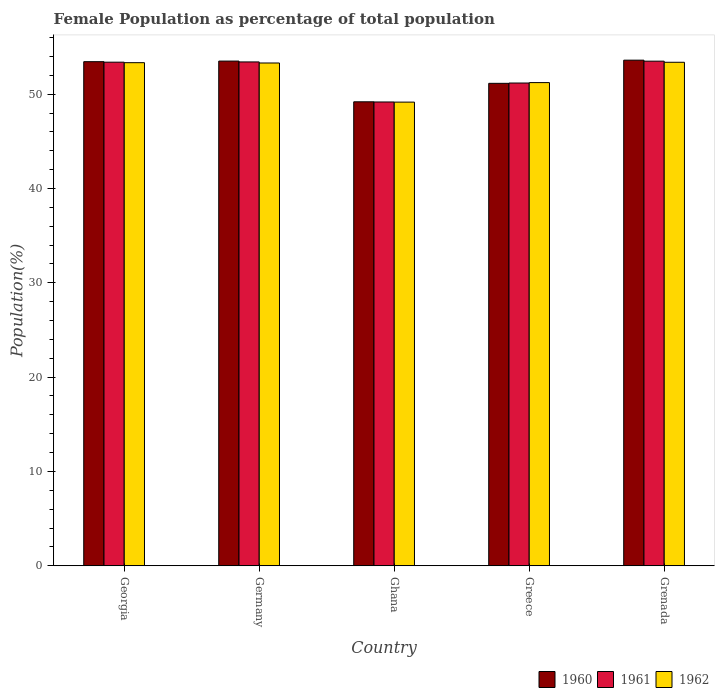Are the number of bars per tick equal to the number of legend labels?
Offer a terse response. Yes. How many bars are there on the 1st tick from the right?
Keep it short and to the point. 3. What is the label of the 5th group of bars from the left?
Your answer should be compact. Grenada. What is the female population in in 1960 in Georgia?
Offer a very short reply. 53.44. Across all countries, what is the maximum female population in in 1961?
Provide a succinct answer. 53.5. Across all countries, what is the minimum female population in in 1962?
Offer a terse response. 49.15. In which country was the female population in in 1960 maximum?
Keep it short and to the point. Grenada. What is the total female population in in 1961 in the graph?
Your answer should be very brief. 260.65. What is the difference between the female population in in 1960 in Germany and that in Greece?
Provide a short and direct response. 2.36. What is the difference between the female population in in 1962 in Greece and the female population in in 1960 in Ghana?
Offer a terse response. 2.04. What is the average female population in in 1961 per country?
Offer a terse response. 52.13. What is the difference between the female population in of/in 1962 and female population in of/in 1961 in Germany?
Keep it short and to the point. -0.11. What is the ratio of the female population in in 1962 in Germany to that in Greece?
Your response must be concise. 1.04. Is the difference between the female population in in 1962 in Georgia and Ghana greater than the difference between the female population in in 1961 in Georgia and Ghana?
Provide a short and direct response. No. What is the difference between the highest and the second highest female population in in 1962?
Keep it short and to the point. -0.03. What is the difference between the highest and the lowest female population in in 1962?
Keep it short and to the point. 4.22. Is the sum of the female population in in 1962 in Georgia and Greece greater than the maximum female population in in 1961 across all countries?
Give a very brief answer. Yes. Is it the case that in every country, the sum of the female population in in 1961 and female population in in 1960 is greater than the female population in in 1962?
Provide a succinct answer. Yes. What is the difference between two consecutive major ticks on the Y-axis?
Offer a terse response. 10. Does the graph contain any zero values?
Your answer should be very brief. No. How are the legend labels stacked?
Offer a terse response. Horizontal. What is the title of the graph?
Provide a succinct answer. Female Population as percentage of total population. What is the label or title of the Y-axis?
Give a very brief answer. Population(%). What is the Population(%) of 1960 in Georgia?
Give a very brief answer. 53.44. What is the Population(%) of 1961 in Georgia?
Make the answer very short. 53.39. What is the Population(%) of 1962 in Georgia?
Offer a very short reply. 53.34. What is the Population(%) of 1960 in Germany?
Provide a short and direct response. 53.5. What is the Population(%) of 1961 in Germany?
Keep it short and to the point. 53.42. What is the Population(%) of 1962 in Germany?
Make the answer very short. 53.3. What is the Population(%) in 1960 in Ghana?
Keep it short and to the point. 49.19. What is the Population(%) in 1961 in Ghana?
Offer a very short reply. 49.17. What is the Population(%) in 1962 in Ghana?
Provide a short and direct response. 49.15. What is the Population(%) in 1960 in Greece?
Make the answer very short. 51.14. What is the Population(%) of 1961 in Greece?
Offer a terse response. 51.18. What is the Population(%) in 1962 in Greece?
Provide a succinct answer. 51.22. What is the Population(%) in 1960 in Grenada?
Provide a succinct answer. 53.6. What is the Population(%) of 1961 in Grenada?
Offer a terse response. 53.5. What is the Population(%) of 1962 in Grenada?
Provide a short and direct response. 53.38. Across all countries, what is the maximum Population(%) in 1960?
Keep it short and to the point. 53.6. Across all countries, what is the maximum Population(%) in 1961?
Make the answer very short. 53.5. Across all countries, what is the maximum Population(%) in 1962?
Keep it short and to the point. 53.38. Across all countries, what is the minimum Population(%) in 1960?
Provide a short and direct response. 49.19. Across all countries, what is the minimum Population(%) of 1961?
Make the answer very short. 49.17. Across all countries, what is the minimum Population(%) in 1962?
Keep it short and to the point. 49.15. What is the total Population(%) in 1960 in the graph?
Offer a very short reply. 260.88. What is the total Population(%) of 1961 in the graph?
Offer a terse response. 260.65. What is the total Population(%) of 1962 in the graph?
Make the answer very short. 260.39. What is the difference between the Population(%) in 1960 in Georgia and that in Germany?
Give a very brief answer. -0.06. What is the difference between the Population(%) in 1961 in Georgia and that in Germany?
Give a very brief answer. -0.03. What is the difference between the Population(%) in 1962 in Georgia and that in Germany?
Give a very brief answer. 0.03. What is the difference between the Population(%) in 1960 in Georgia and that in Ghana?
Provide a succinct answer. 4.25. What is the difference between the Population(%) of 1961 in Georgia and that in Ghana?
Give a very brief answer. 4.22. What is the difference between the Population(%) in 1962 in Georgia and that in Ghana?
Provide a succinct answer. 4.18. What is the difference between the Population(%) of 1960 in Georgia and that in Greece?
Give a very brief answer. 2.3. What is the difference between the Population(%) in 1961 in Georgia and that in Greece?
Offer a terse response. 2.21. What is the difference between the Population(%) in 1962 in Georgia and that in Greece?
Provide a short and direct response. 2.11. What is the difference between the Population(%) of 1960 in Georgia and that in Grenada?
Give a very brief answer. -0.16. What is the difference between the Population(%) of 1961 in Georgia and that in Grenada?
Offer a terse response. -0.11. What is the difference between the Population(%) in 1962 in Georgia and that in Grenada?
Offer a very short reply. -0.04. What is the difference between the Population(%) of 1960 in Germany and that in Ghana?
Provide a short and direct response. 4.32. What is the difference between the Population(%) in 1961 in Germany and that in Ghana?
Your answer should be very brief. 4.25. What is the difference between the Population(%) in 1962 in Germany and that in Ghana?
Your response must be concise. 4.15. What is the difference between the Population(%) in 1960 in Germany and that in Greece?
Ensure brevity in your answer.  2.36. What is the difference between the Population(%) in 1961 in Germany and that in Greece?
Keep it short and to the point. 2.24. What is the difference between the Population(%) of 1962 in Germany and that in Greece?
Your answer should be compact. 2.08. What is the difference between the Population(%) of 1960 in Germany and that in Grenada?
Provide a succinct answer. -0.1. What is the difference between the Population(%) of 1961 in Germany and that in Grenada?
Your answer should be compact. -0.08. What is the difference between the Population(%) of 1962 in Germany and that in Grenada?
Ensure brevity in your answer.  -0.07. What is the difference between the Population(%) of 1960 in Ghana and that in Greece?
Offer a terse response. -1.96. What is the difference between the Population(%) in 1961 in Ghana and that in Greece?
Provide a succinct answer. -2.01. What is the difference between the Population(%) in 1962 in Ghana and that in Greece?
Provide a short and direct response. -2.07. What is the difference between the Population(%) of 1960 in Ghana and that in Grenada?
Provide a succinct answer. -4.42. What is the difference between the Population(%) of 1961 in Ghana and that in Grenada?
Your answer should be very brief. -4.33. What is the difference between the Population(%) in 1962 in Ghana and that in Grenada?
Keep it short and to the point. -4.22. What is the difference between the Population(%) of 1960 in Greece and that in Grenada?
Your response must be concise. -2.46. What is the difference between the Population(%) of 1961 in Greece and that in Grenada?
Provide a succinct answer. -2.32. What is the difference between the Population(%) in 1962 in Greece and that in Grenada?
Provide a short and direct response. -2.15. What is the difference between the Population(%) in 1960 in Georgia and the Population(%) in 1961 in Germany?
Your response must be concise. 0.03. What is the difference between the Population(%) of 1960 in Georgia and the Population(%) of 1962 in Germany?
Provide a short and direct response. 0.14. What is the difference between the Population(%) in 1961 in Georgia and the Population(%) in 1962 in Germany?
Ensure brevity in your answer.  0.09. What is the difference between the Population(%) in 1960 in Georgia and the Population(%) in 1961 in Ghana?
Ensure brevity in your answer.  4.27. What is the difference between the Population(%) in 1960 in Georgia and the Population(%) in 1962 in Ghana?
Your answer should be very brief. 4.29. What is the difference between the Population(%) in 1961 in Georgia and the Population(%) in 1962 in Ghana?
Provide a succinct answer. 4.23. What is the difference between the Population(%) of 1960 in Georgia and the Population(%) of 1961 in Greece?
Offer a very short reply. 2.26. What is the difference between the Population(%) of 1960 in Georgia and the Population(%) of 1962 in Greece?
Your response must be concise. 2.22. What is the difference between the Population(%) in 1961 in Georgia and the Population(%) in 1962 in Greece?
Give a very brief answer. 2.17. What is the difference between the Population(%) in 1960 in Georgia and the Population(%) in 1961 in Grenada?
Offer a terse response. -0.05. What is the difference between the Population(%) of 1960 in Georgia and the Population(%) of 1962 in Grenada?
Your answer should be very brief. 0.06. What is the difference between the Population(%) in 1961 in Georgia and the Population(%) in 1962 in Grenada?
Offer a terse response. 0.01. What is the difference between the Population(%) of 1960 in Germany and the Population(%) of 1961 in Ghana?
Ensure brevity in your answer.  4.33. What is the difference between the Population(%) in 1960 in Germany and the Population(%) in 1962 in Ghana?
Your response must be concise. 4.35. What is the difference between the Population(%) in 1961 in Germany and the Population(%) in 1962 in Ghana?
Make the answer very short. 4.26. What is the difference between the Population(%) in 1960 in Germany and the Population(%) in 1961 in Greece?
Give a very brief answer. 2.33. What is the difference between the Population(%) of 1960 in Germany and the Population(%) of 1962 in Greece?
Offer a terse response. 2.28. What is the difference between the Population(%) of 1961 in Germany and the Population(%) of 1962 in Greece?
Your answer should be very brief. 2.19. What is the difference between the Population(%) of 1960 in Germany and the Population(%) of 1961 in Grenada?
Offer a very short reply. 0.01. What is the difference between the Population(%) in 1960 in Germany and the Population(%) in 1962 in Grenada?
Keep it short and to the point. 0.13. What is the difference between the Population(%) in 1961 in Germany and the Population(%) in 1962 in Grenada?
Provide a short and direct response. 0.04. What is the difference between the Population(%) of 1960 in Ghana and the Population(%) of 1961 in Greece?
Keep it short and to the point. -1.99. What is the difference between the Population(%) of 1960 in Ghana and the Population(%) of 1962 in Greece?
Make the answer very short. -2.04. What is the difference between the Population(%) of 1961 in Ghana and the Population(%) of 1962 in Greece?
Provide a succinct answer. -2.05. What is the difference between the Population(%) of 1960 in Ghana and the Population(%) of 1961 in Grenada?
Give a very brief answer. -4.31. What is the difference between the Population(%) of 1960 in Ghana and the Population(%) of 1962 in Grenada?
Offer a very short reply. -4.19. What is the difference between the Population(%) of 1961 in Ghana and the Population(%) of 1962 in Grenada?
Your response must be concise. -4.21. What is the difference between the Population(%) in 1960 in Greece and the Population(%) in 1961 in Grenada?
Provide a succinct answer. -2.35. What is the difference between the Population(%) in 1960 in Greece and the Population(%) in 1962 in Grenada?
Provide a succinct answer. -2.23. What is the difference between the Population(%) of 1961 in Greece and the Population(%) of 1962 in Grenada?
Make the answer very short. -2.2. What is the average Population(%) of 1960 per country?
Offer a very short reply. 52.18. What is the average Population(%) in 1961 per country?
Provide a short and direct response. 52.13. What is the average Population(%) in 1962 per country?
Make the answer very short. 52.08. What is the difference between the Population(%) in 1960 and Population(%) in 1961 in Georgia?
Provide a short and direct response. 0.05. What is the difference between the Population(%) in 1960 and Population(%) in 1962 in Georgia?
Your answer should be compact. 0.11. What is the difference between the Population(%) of 1961 and Population(%) of 1962 in Georgia?
Provide a succinct answer. 0.05. What is the difference between the Population(%) in 1960 and Population(%) in 1961 in Germany?
Your answer should be compact. 0.09. What is the difference between the Population(%) in 1960 and Population(%) in 1962 in Germany?
Your response must be concise. 0.2. What is the difference between the Population(%) of 1961 and Population(%) of 1962 in Germany?
Give a very brief answer. 0.11. What is the difference between the Population(%) in 1960 and Population(%) in 1961 in Ghana?
Your answer should be very brief. 0.02. What is the difference between the Population(%) of 1960 and Population(%) of 1962 in Ghana?
Provide a succinct answer. 0.03. What is the difference between the Population(%) in 1961 and Population(%) in 1962 in Ghana?
Offer a terse response. 0.02. What is the difference between the Population(%) of 1960 and Population(%) of 1961 in Greece?
Your response must be concise. -0.03. What is the difference between the Population(%) of 1960 and Population(%) of 1962 in Greece?
Keep it short and to the point. -0.08. What is the difference between the Population(%) in 1961 and Population(%) in 1962 in Greece?
Offer a very short reply. -0.05. What is the difference between the Population(%) of 1960 and Population(%) of 1961 in Grenada?
Your answer should be compact. 0.11. What is the difference between the Population(%) of 1960 and Population(%) of 1962 in Grenada?
Offer a very short reply. 0.22. What is the difference between the Population(%) of 1961 and Population(%) of 1962 in Grenada?
Provide a short and direct response. 0.12. What is the ratio of the Population(%) of 1960 in Georgia to that in Germany?
Offer a very short reply. 1. What is the ratio of the Population(%) in 1961 in Georgia to that in Germany?
Give a very brief answer. 1. What is the ratio of the Population(%) of 1960 in Georgia to that in Ghana?
Your answer should be very brief. 1.09. What is the ratio of the Population(%) in 1961 in Georgia to that in Ghana?
Your answer should be very brief. 1.09. What is the ratio of the Population(%) of 1962 in Georgia to that in Ghana?
Your answer should be compact. 1.09. What is the ratio of the Population(%) in 1960 in Georgia to that in Greece?
Your answer should be compact. 1.04. What is the ratio of the Population(%) of 1961 in Georgia to that in Greece?
Offer a very short reply. 1.04. What is the ratio of the Population(%) in 1962 in Georgia to that in Greece?
Your answer should be compact. 1.04. What is the ratio of the Population(%) in 1960 in Georgia to that in Grenada?
Your answer should be compact. 1. What is the ratio of the Population(%) of 1962 in Georgia to that in Grenada?
Make the answer very short. 1. What is the ratio of the Population(%) in 1960 in Germany to that in Ghana?
Provide a short and direct response. 1.09. What is the ratio of the Population(%) in 1961 in Germany to that in Ghana?
Your answer should be very brief. 1.09. What is the ratio of the Population(%) of 1962 in Germany to that in Ghana?
Your answer should be very brief. 1.08. What is the ratio of the Population(%) of 1960 in Germany to that in Greece?
Provide a short and direct response. 1.05. What is the ratio of the Population(%) in 1961 in Germany to that in Greece?
Your answer should be very brief. 1.04. What is the ratio of the Population(%) in 1962 in Germany to that in Greece?
Your answer should be compact. 1.04. What is the ratio of the Population(%) of 1960 in Germany to that in Grenada?
Provide a succinct answer. 1. What is the ratio of the Population(%) of 1962 in Germany to that in Grenada?
Provide a succinct answer. 1. What is the ratio of the Population(%) in 1960 in Ghana to that in Greece?
Offer a very short reply. 0.96. What is the ratio of the Population(%) of 1961 in Ghana to that in Greece?
Your response must be concise. 0.96. What is the ratio of the Population(%) of 1962 in Ghana to that in Greece?
Your response must be concise. 0.96. What is the ratio of the Population(%) in 1960 in Ghana to that in Grenada?
Give a very brief answer. 0.92. What is the ratio of the Population(%) in 1961 in Ghana to that in Grenada?
Ensure brevity in your answer.  0.92. What is the ratio of the Population(%) in 1962 in Ghana to that in Grenada?
Offer a very short reply. 0.92. What is the ratio of the Population(%) of 1960 in Greece to that in Grenada?
Offer a terse response. 0.95. What is the ratio of the Population(%) of 1961 in Greece to that in Grenada?
Offer a terse response. 0.96. What is the ratio of the Population(%) in 1962 in Greece to that in Grenada?
Offer a very short reply. 0.96. What is the difference between the highest and the second highest Population(%) in 1960?
Keep it short and to the point. 0.1. What is the difference between the highest and the second highest Population(%) in 1961?
Offer a terse response. 0.08. What is the difference between the highest and the second highest Population(%) in 1962?
Ensure brevity in your answer.  0.04. What is the difference between the highest and the lowest Population(%) in 1960?
Your response must be concise. 4.42. What is the difference between the highest and the lowest Population(%) in 1961?
Your answer should be very brief. 4.33. What is the difference between the highest and the lowest Population(%) of 1962?
Give a very brief answer. 4.22. 